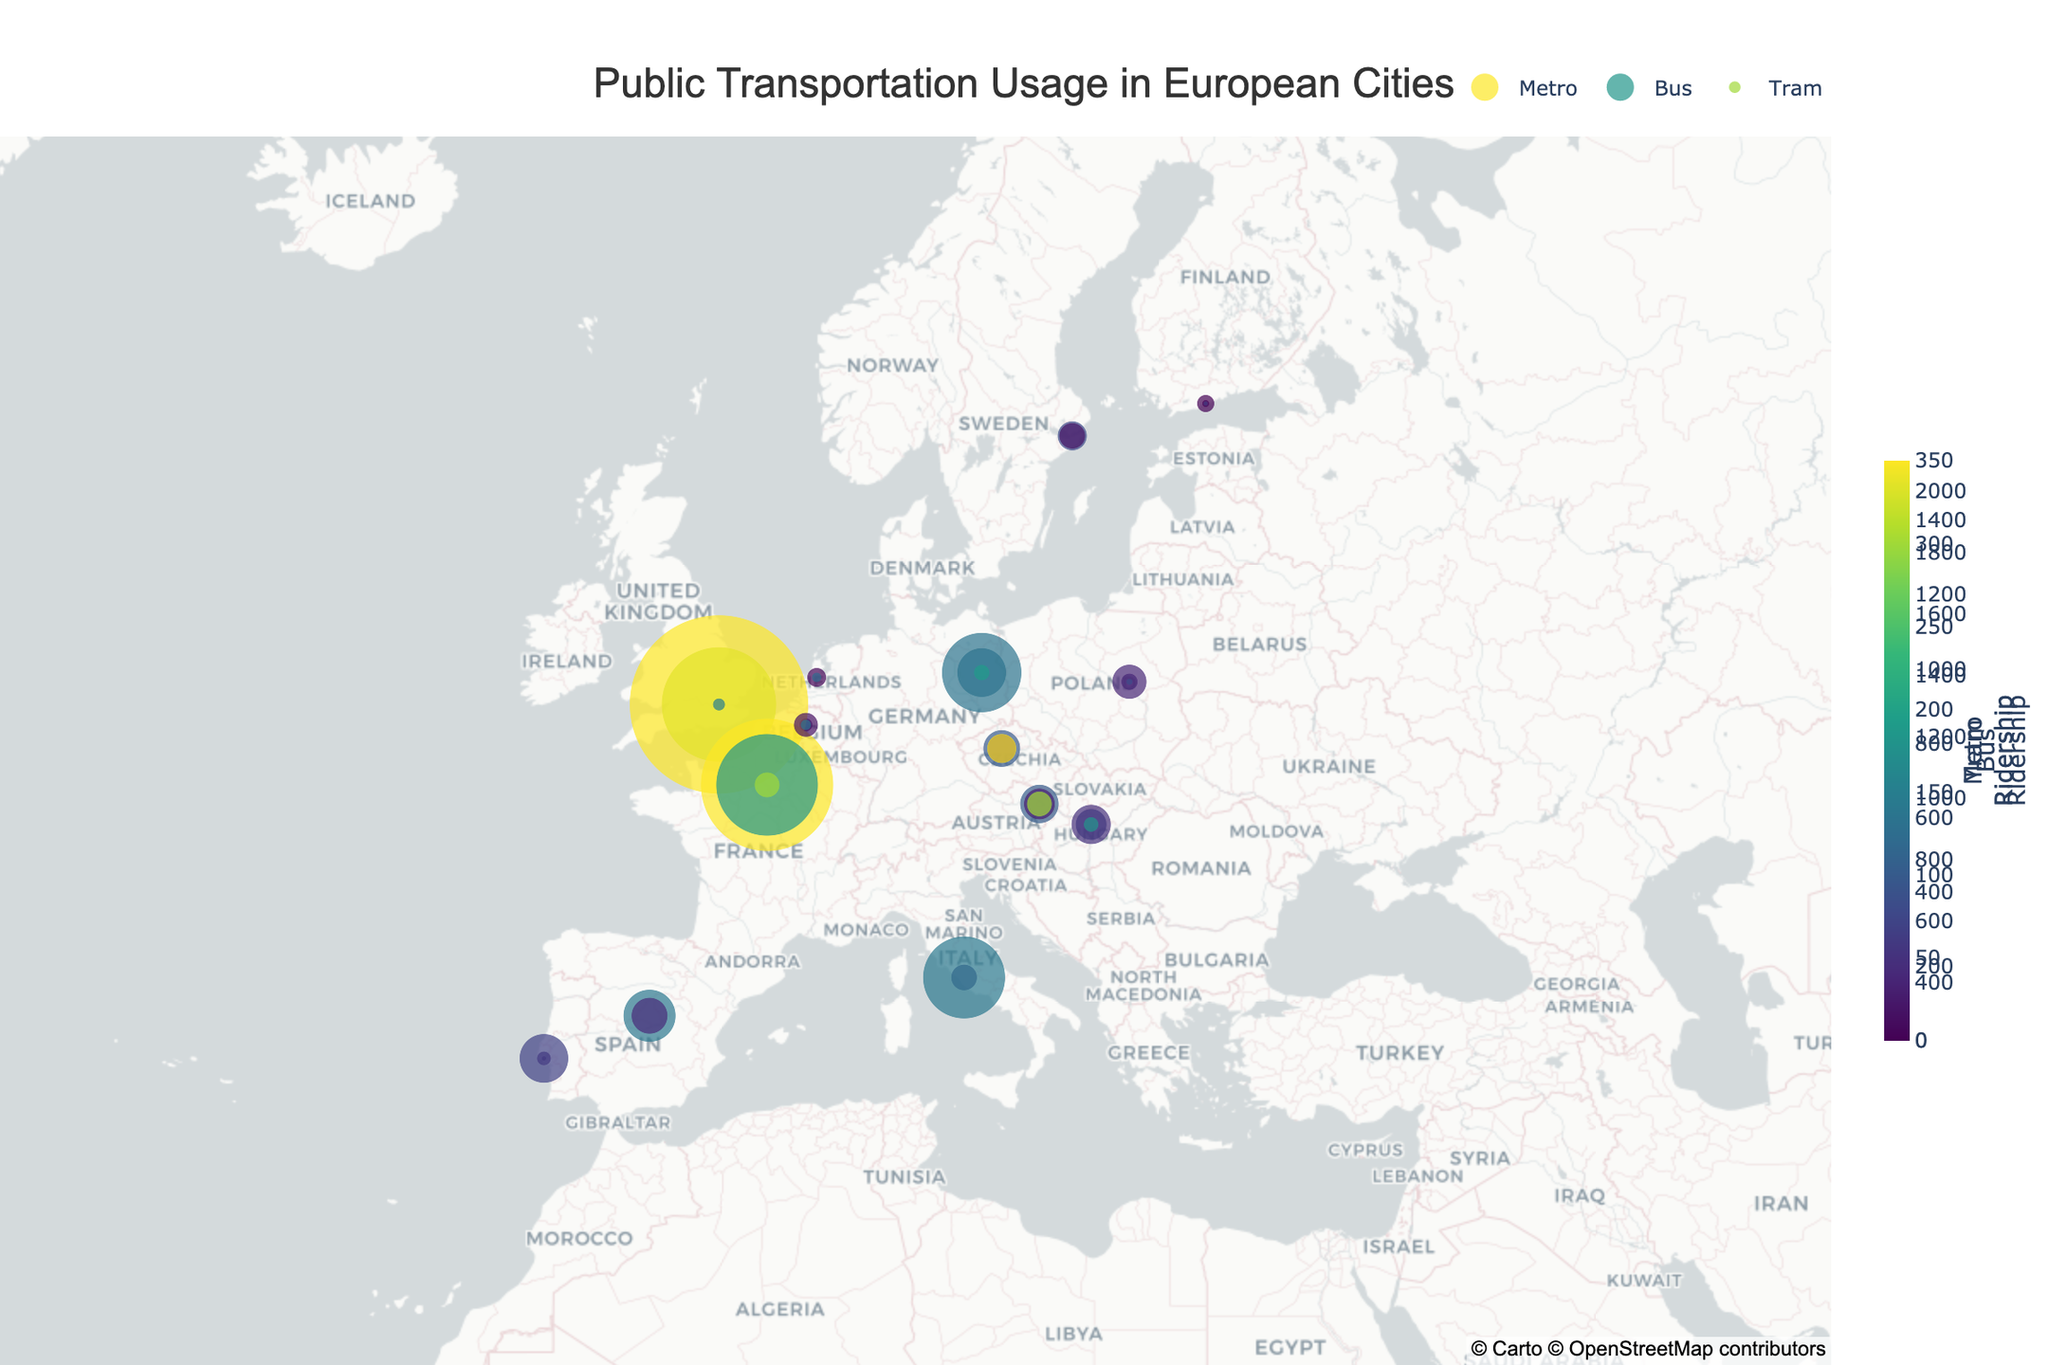What's the title of the figure? The title of the figure is usually displayed at the top and summarizes the main topic or information presented. Here, it is "Public Transportation Usage in European Cities".
Answer: Public Transportation Usage in European Cities Which city has the largest metro ridership? By examining the metro ridership values on the map, the city with the largest value is 1560, which corresponds to Paris.
Answer: Paris How many cities have metro ridership but no tram ridership? By checking the metro and tram ridership values: Madrid (620, 0), Stockholm (350, 0), and Rome (310, 0) have metro ridership and zero tram ridership. So the answer is three.
Answer: 3 What is the total bus ridership for London and Berlin? Add the bus ridership values for London (2100) and Berlin (940) together. 2100 + 940 = 3040.
Answer: 3040 Among metro, bus, and tram, which type of public transportation has the highest ridership in Vienna? For Vienna, the ridership values are 460 for metro, 370 for bus, and 300 for tram. Metro has the highest ridership.
Answer: Metro Which city has a higher tram ridership, Prague or Amsterdam? Check the tram ridership entries: Prague has 350 and Amsterdam has 120. Therefore, Prague has higher tram ridership.
Answer: Prague Which country has the city with the highest bus ridership? Look at the bus ridership values and find the highest value, which is 2100, corresponding to London in the UK.
Answer: UK Average metro ridership of cities with more than 500 metro ridership? The cities with metro ridership more than 500 are Paris (1560), London (1350), Berlin (580), and Madrid (620). Summing these: 1560 + 1350 + 580 + 620 = 4110. The number of such cities is 4. Therefore, the average is 4110 / 4 = 1027.5.
Answer: 1027.5 Which city has a lower metro ridership, Helsinki or Brussels? Compare the metro ridership values: Helsinki has 90, and Brussels has 160. Helsinki has the lower metro ridership.
Answer: Helsinki What is the combined tram ridership for cities without metro systems? The cities without metro systems are Amsterdam and Stockholm. Their tram ridership values are 120 and 0, respectively. Combining these: 120 + 0 =125.
Answer: 120 